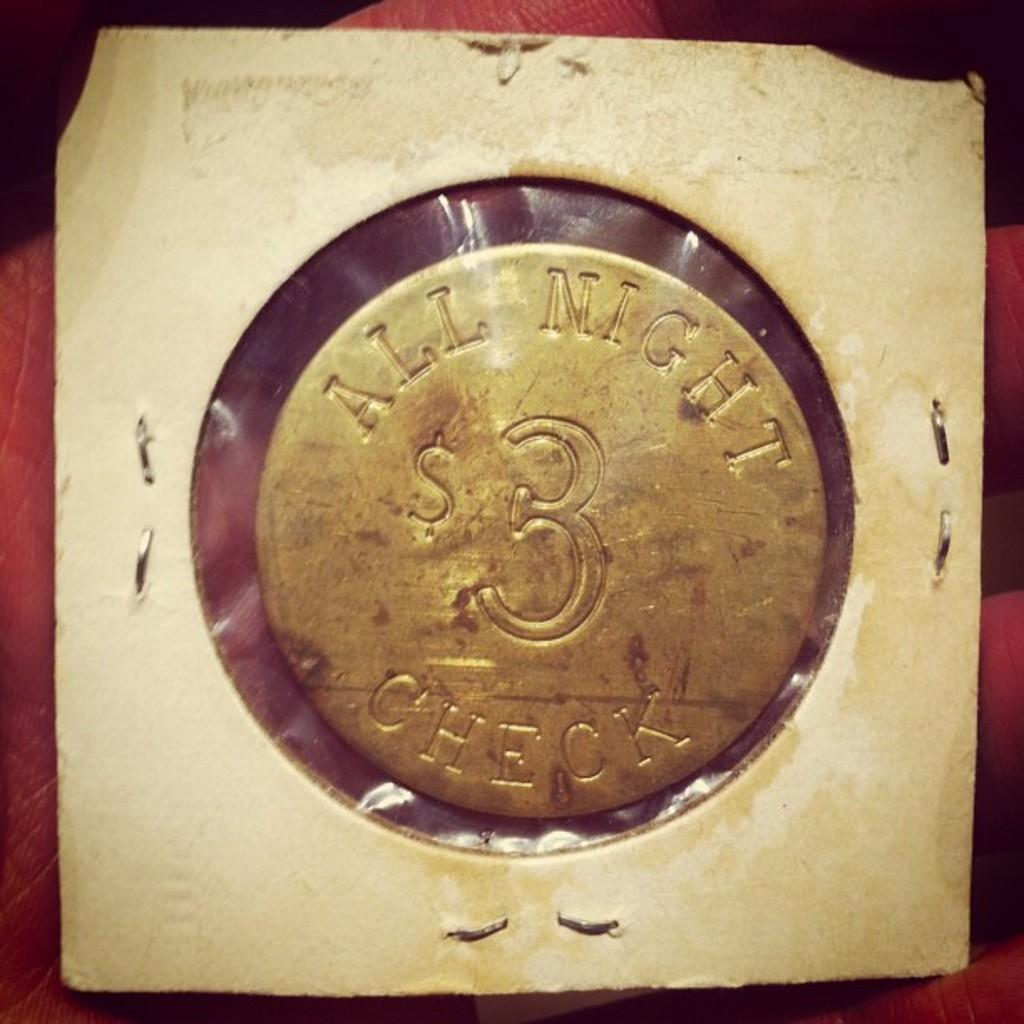Provide a one-sentence caption for the provided image. A metallic circle has "ALL MIGHT CHECK" engraved into it. 